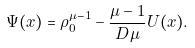Convert formula to latex. <formula><loc_0><loc_0><loc_500><loc_500>\Psi ( x ) = \rho _ { 0 } ^ { \mu - 1 } - \frac { \mu - 1 } { D \mu } U ( x ) .</formula> 